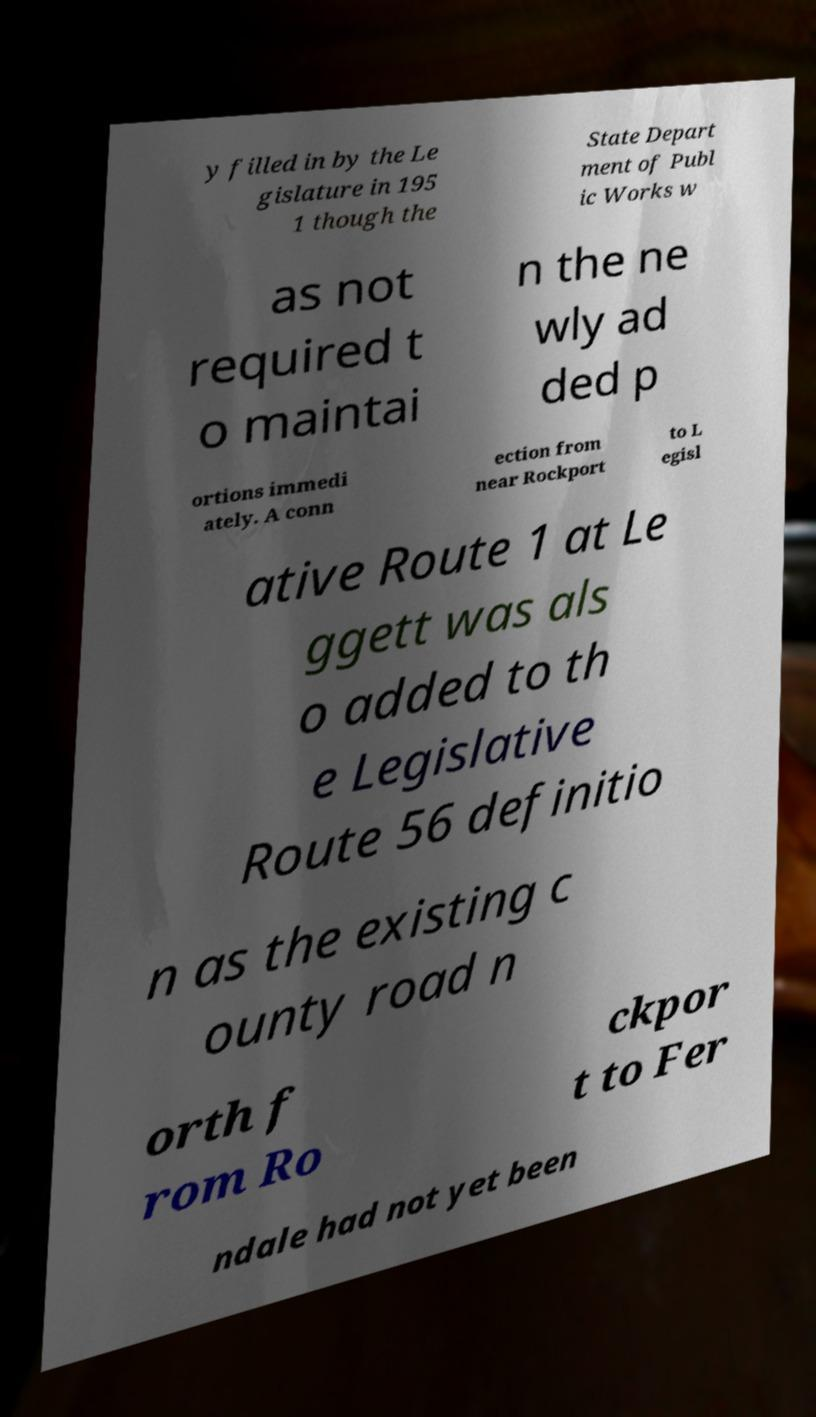Could you extract and type out the text from this image? y filled in by the Le gislature in 195 1 though the State Depart ment of Publ ic Works w as not required t o maintai n the ne wly ad ded p ortions immedi ately. A conn ection from near Rockport to L egisl ative Route 1 at Le ggett was als o added to th e Legislative Route 56 definitio n as the existing c ounty road n orth f rom Ro ckpor t to Fer ndale had not yet been 